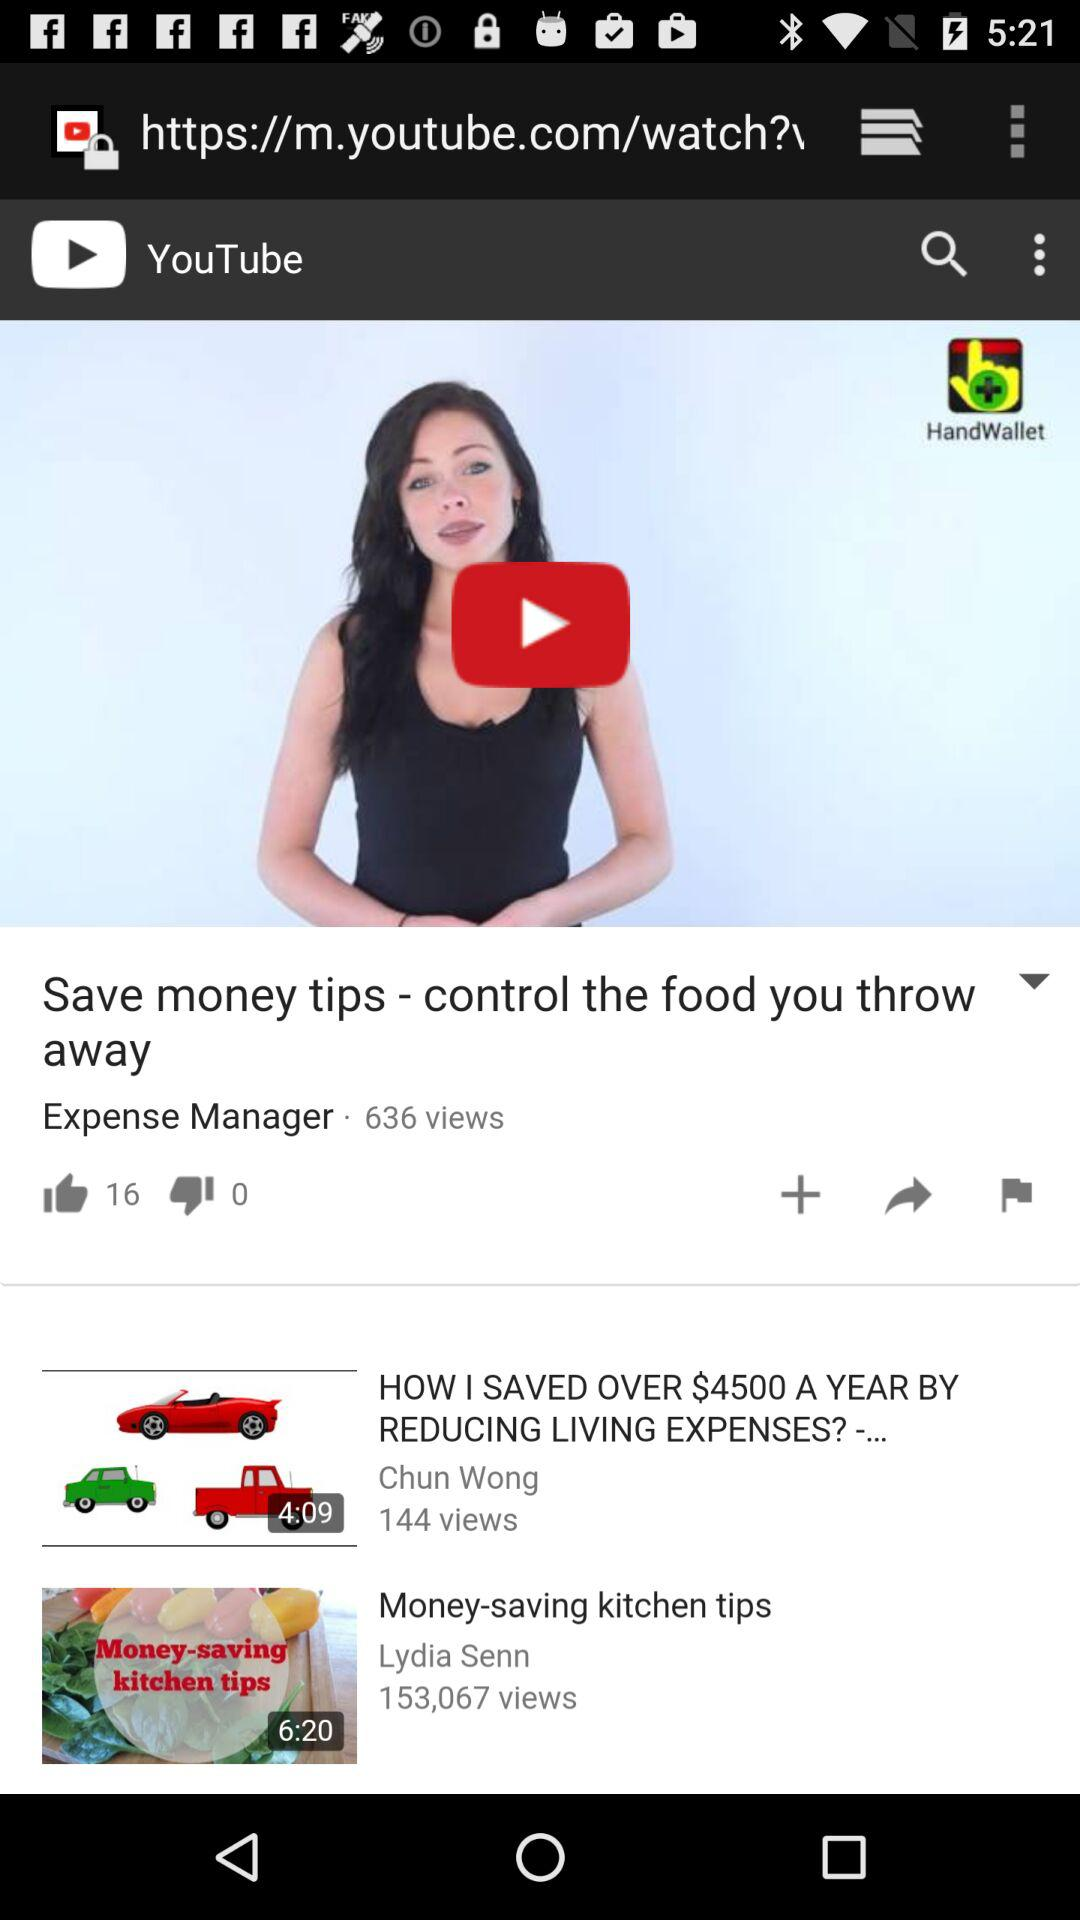What video duration is 6:20 minutes? The video is "Money-saving kitchen tips". 